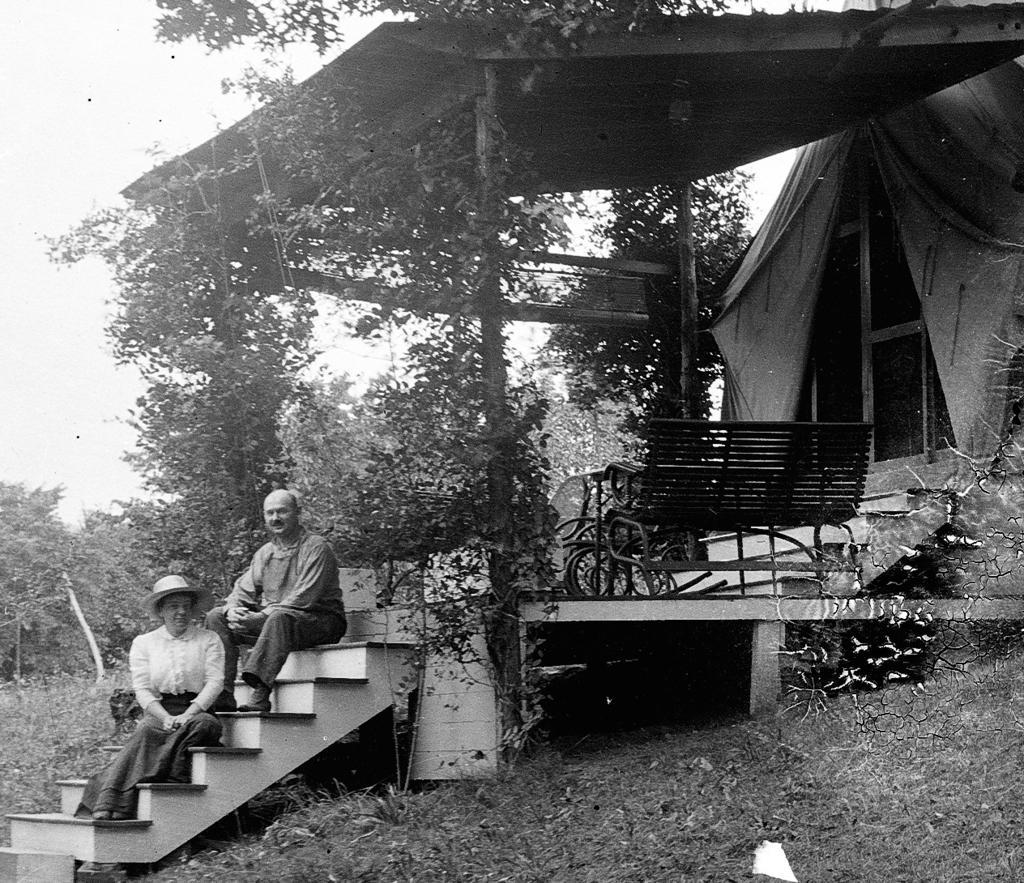Please provide a concise description of this image. This is a black and white image. In this image we can see house, trees, plants, benches, stairs, persons, grass and sky. 